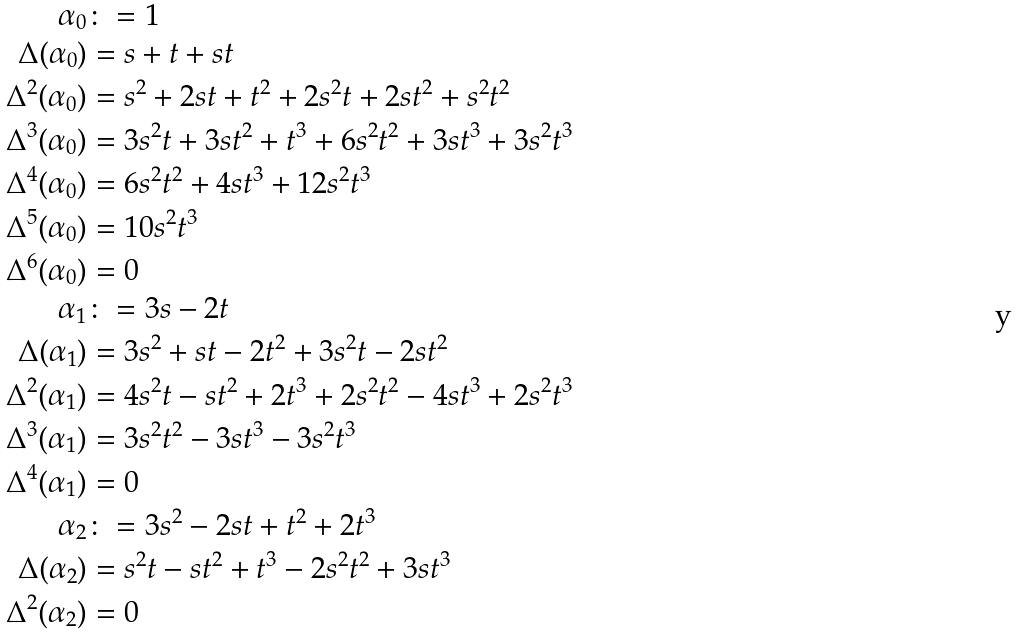<formula> <loc_0><loc_0><loc_500><loc_500>\alpha _ { 0 } & \colon = 1 \\ \Delta ( \alpha _ { 0 } ) & = s + t + s t \\ \Delta ^ { 2 } ( \alpha _ { 0 } ) & = s ^ { 2 } + 2 s t + t ^ { 2 } + 2 s ^ { 2 } t + 2 s t ^ { 2 } + s ^ { 2 } t ^ { 2 } \\ \Delta ^ { 3 } ( \alpha _ { 0 } ) & = 3 s ^ { 2 } t + 3 s t ^ { 2 } + t ^ { 3 } + 6 s ^ { 2 } t ^ { 2 } + 3 s t ^ { 3 } + 3 s ^ { 2 } t ^ { 3 } \\ \Delta ^ { 4 } ( \alpha _ { 0 } ) & = 6 s ^ { 2 } t ^ { 2 } + 4 s t ^ { 3 } + 1 2 s ^ { 2 } t ^ { 3 } \\ \Delta ^ { 5 } ( \alpha _ { 0 } ) & = 1 0 s ^ { 2 } t ^ { 3 } \\ \Delta ^ { 6 } ( \alpha _ { 0 } ) & = 0 \\ \alpha _ { 1 } & \colon = 3 s - 2 t \\ \Delta ( \alpha _ { 1 } ) & = 3 s ^ { 2 } + s t - 2 t ^ { 2 } + 3 s ^ { 2 } t - 2 s t ^ { 2 } \\ \Delta ^ { 2 } ( \alpha _ { 1 } ) & = 4 s ^ { 2 } t - s t ^ { 2 } + 2 t ^ { 3 } + 2 s ^ { 2 } t ^ { 2 } - 4 s t ^ { 3 } + 2 s ^ { 2 } t ^ { 3 } \\ \Delta ^ { 3 } ( \alpha _ { 1 } ) & = 3 s ^ { 2 } t ^ { 2 } - 3 s t ^ { 3 } - 3 s ^ { 2 } t ^ { 3 } \\ \Delta ^ { 4 } ( \alpha _ { 1 } ) & = 0 \\ \alpha _ { 2 } & \colon = 3 s ^ { 2 } - 2 s t + t ^ { 2 } + 2 t ^ { 3 } \\ \Delta ( \alpha _ { 2 } ) & = s ^ { 2 } t - s t ^ { 2 } + t ^ { 3 } - 2 s ^ { 2 } t ^ { 2 } + 3 s t ^ { 3 } \\ \Delta ^ { 2 } ( \alpha _ { 2 } ) & = 0</formula> 